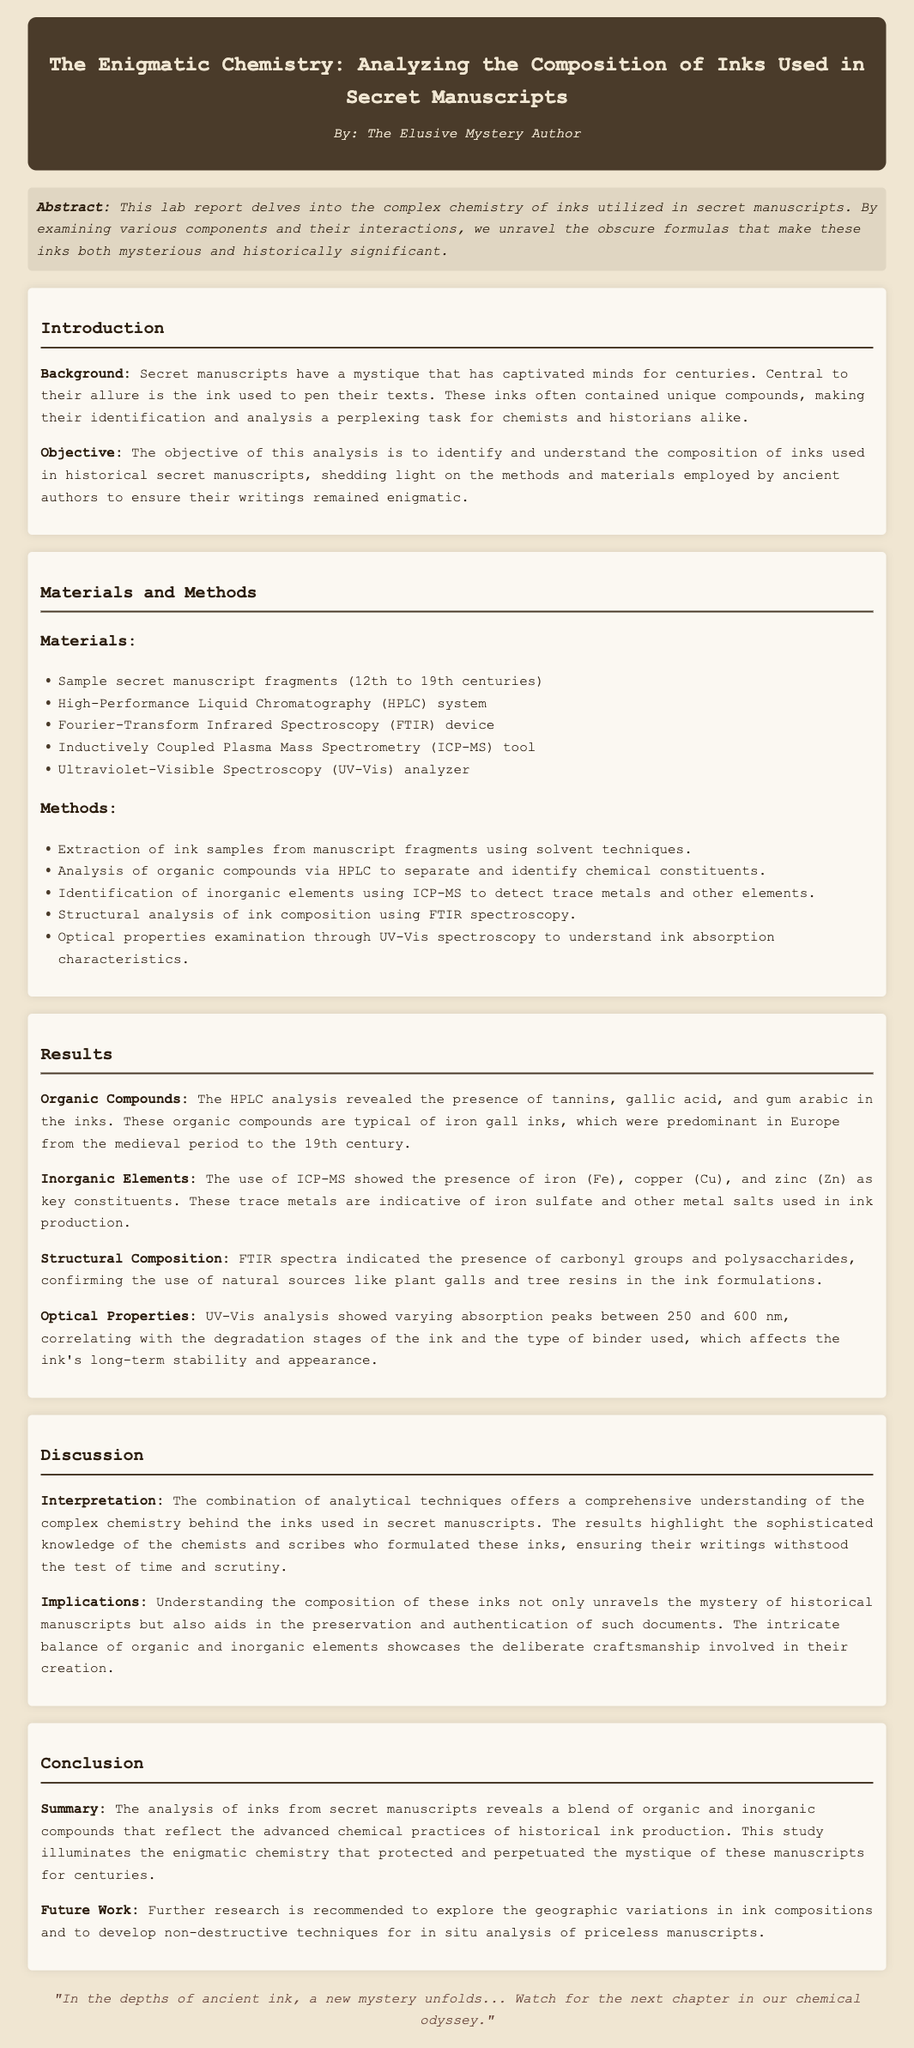What is the title of the lab report? The title of the lab report provides insight into the main focus of the study, which is the analysis of inks used in secret manuscripts.
Answer: The Enigmatic Chemistry: Analyzing the Composition of Inks Used in Secret Manuscripts Who is the author of the report? The author is mentioned at the top of the document, indicating the person responsible for the content.
Answer: The Elusive Mystery Author What techniques were used for structural analysis? The document lists various analytical techniques, specifying the method used for structural analysis of inks.
Answer: FTIR spectroscopy What were the organic compounds identified in the inks? The results section enumerates the specific organic compounds found in the inks analyzed from the manuscripts.
Answer: Tannins, gallic acid, and gum arabic What is the focus of the future work suggested in the conclusion? The conclusion outlines future research directions, mentioning a specific area for further investigation related to the study.
Answer: Geographic variations in ink compositions What inorganic elements were detected in the inks? The report mentions specific trace metals found during the analysis conducted by the ICP-MS technique.
Answer: Iron, copper, and zinc What is the significance of understanding ink composition according to the discussion? The discussion highlights the implications of the results for both historical documents and their preservation.
Answer: Preservation and authentication How many sample manuscript fragments were examined? The materials section states the number of manuscript fragments analyzed for the study.
Answer: Sample secret manuscript fragments (12th to 19th centuries) 